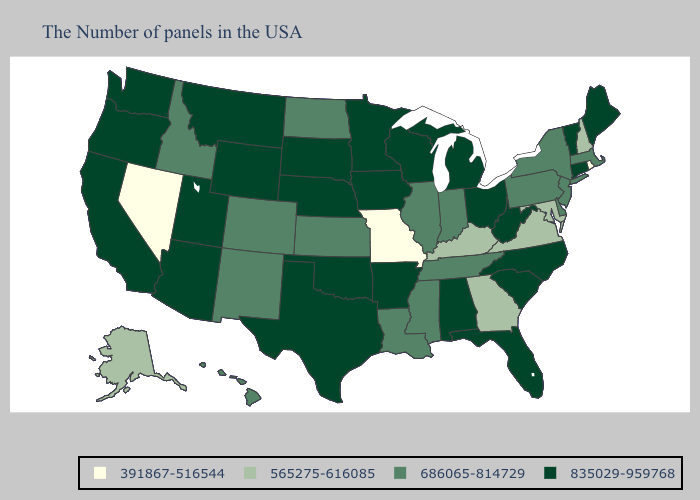What is the lowest value in the USA?
Keep it brief. 391867-516544. Name the states that have a value in the range 835029-959768?
Quick response, please. Maine, Vermont, Connecticut, North Carolina, South Carolina, West Virginia, Ohio, Florida, Michigan, Alabama, Wisconsin, Arkansas, Minnesota, Iowa, Nebraska, Oklahoma, Texas, South Dakota, Wyoming, Utah, Montana, Arizona, California, Washington, Oregon. Does New Hampshire have the lowest value in the Northeast?
Concise answer only. No. Among the states that border Florida , does Georgia have the lowest value?
Write a very short answer. Yes. Which states have the lowest value in the MidWest?
Concise answer only. Missouri. Name the states that have a value in the range 835029-959768?
Write a very short answer. Maine, Vermont, Connecticut, North Carolina, South Carolina, West Virginia, Ohio, Florida, Michigan, Alabama, Wisconsin, Arkansas, Minnesota, Iowa, Nebraska, Oklahoma, Texas, South Dakota, Wyoming, Utah, Montana, Arizona, California, Washington, Oregon. Is the legend a continuous bar?
Short answer required. No. Name the states that have a value in the range 835029-959768?
Concise answer only. Maine, Vermont, Connecticut, North Carolina, South Carolina, West Virginia, Ohio, Florida, Michigan, Alabama, Wisconsin, Arkansas, Minnesota, Iowa, Nebraska, Oklahoma, Texas, South Dakota, Wyoming, Utah, Montana, Arizona, California, Washington, Oregon. What is the lowest value in the South?
Write a very short answer. 565275-616085. What is the value of Kansas?
Concise answer only. 686065-814729. What is the value of Texas?
Give a very brief answer. 835029-959768. Does the map have missing data?
Short answer required. No. What is the lowest value in the USA?
Quick response, please. 391867-516544. Does the first symbol in the legend represent the smallest category?
Keep it brief. Yes. Does the map have missing data?
Answer briefly. No. 